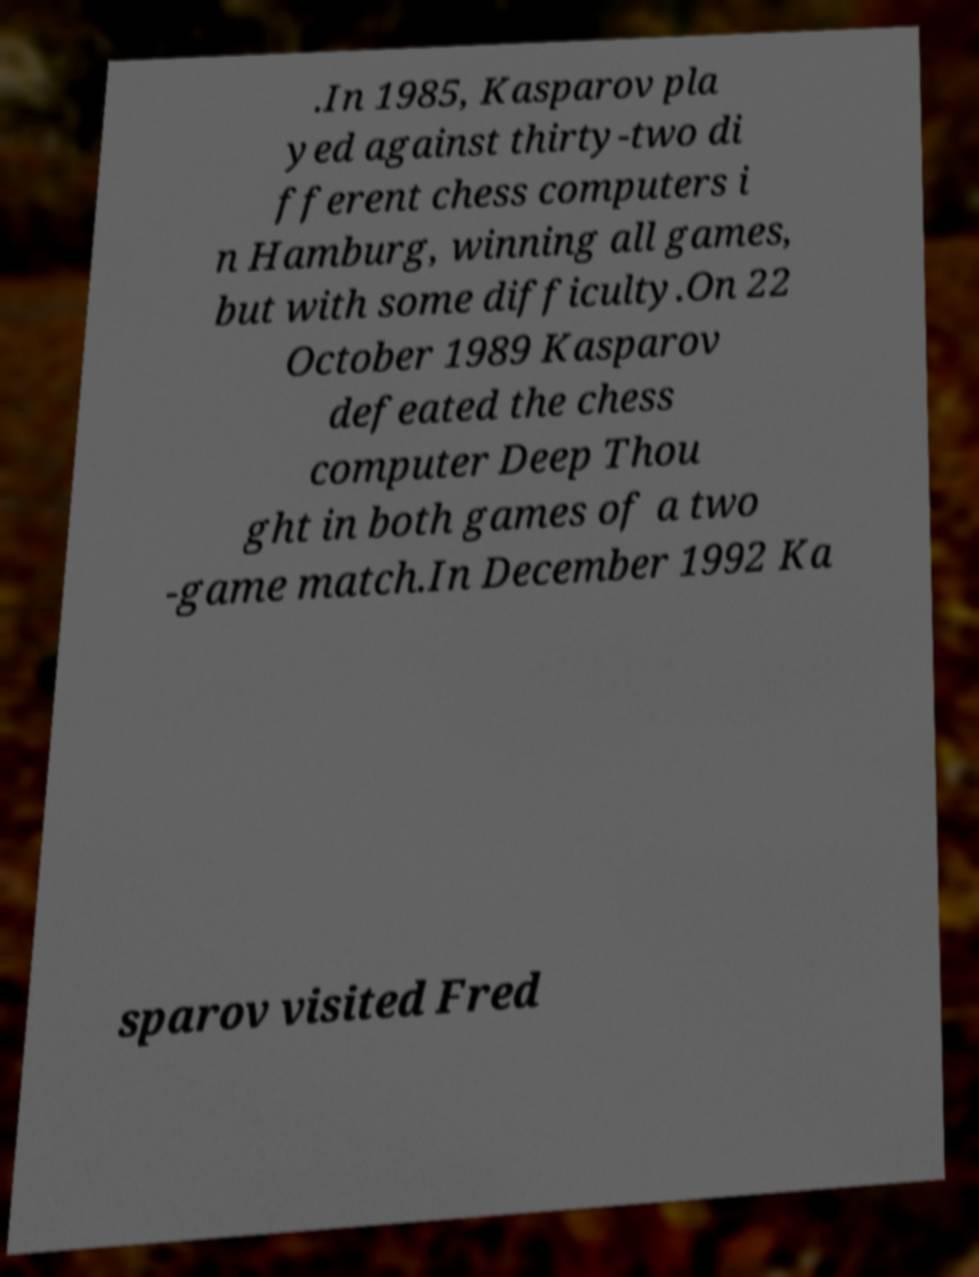Please read and relay the text visible in this image. What does it say? .In 1985, Kasparov pla yed against thirty-two di fferent chess computers i n Hamburg, winning all games, but with some difficulty.On 22 October 1989 Kasparov defeated the chess computer Deep Thou ght in both games of a two -game match.In December 1992 Ka sparov visited Fred 